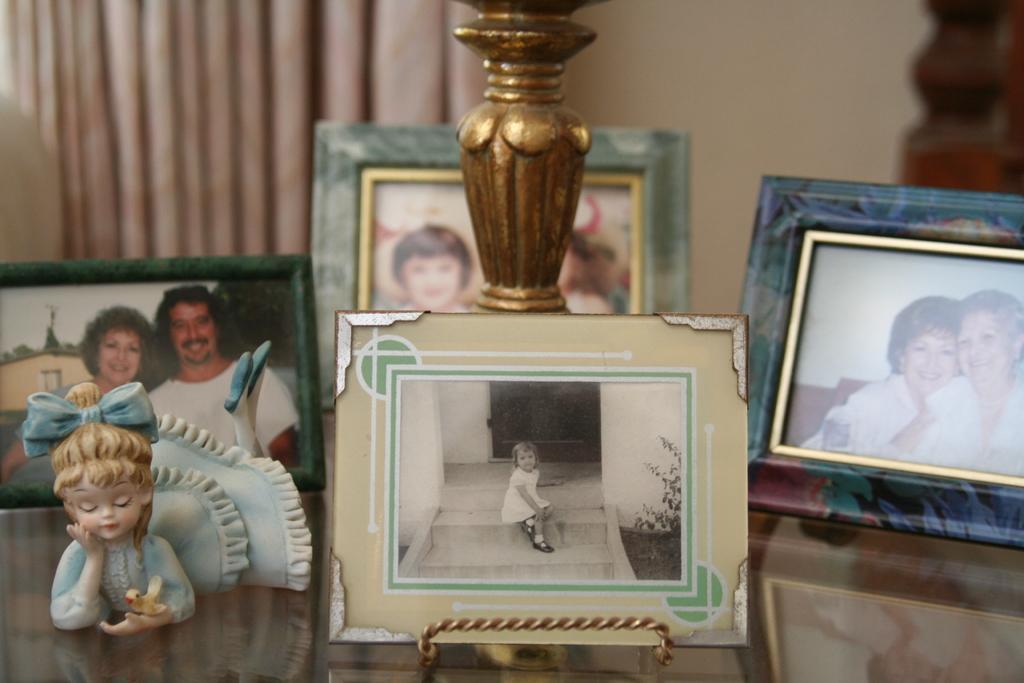Please provide a concise description of this image. In this image there are some photo frames and one toy, at the bottom it looks like a table. And in the background there is a curtain, wall and wooden poles. And in the center there is some object. 